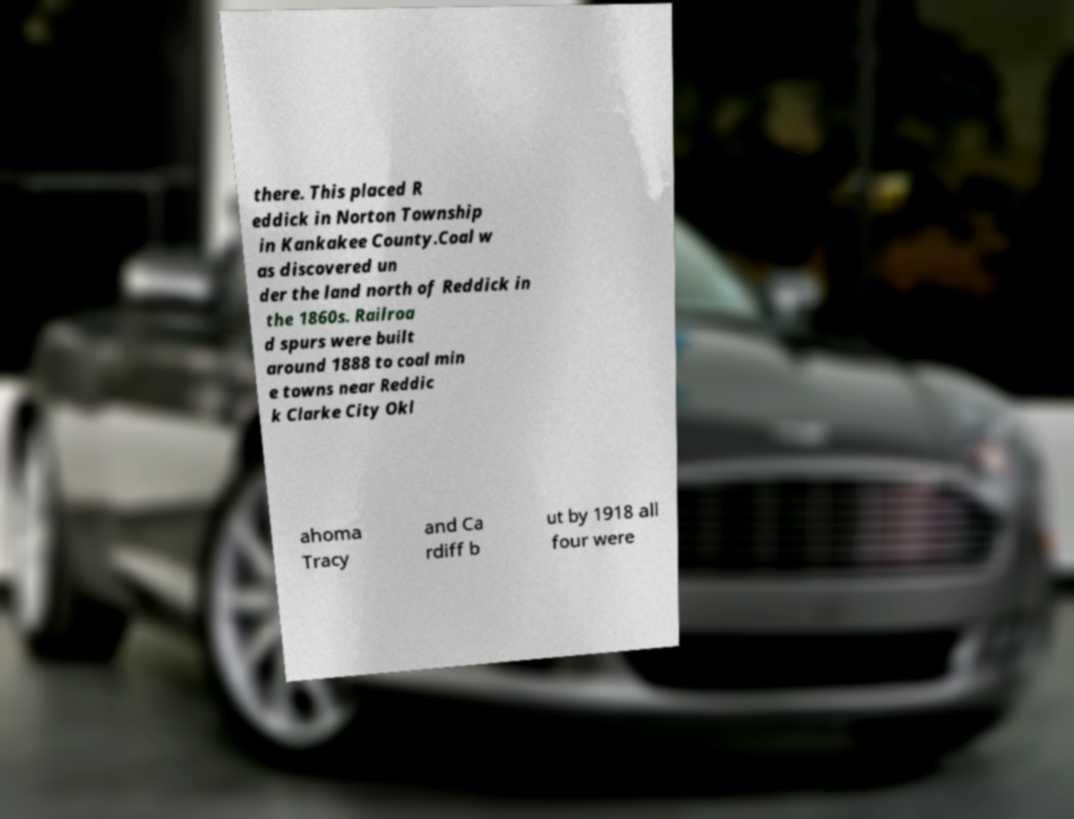Could you assist in decoding the text presented in this image and type it out clearly? there. This placed R eddick in Norton Township in Kankakee County.Coal w as discovered un der the land north of Reddick in the 1860s. Railroa d spurs were built around 1888 to coal min e towns near Reddic k Clarke City Okl ahoma Tracy and Ca rdiff b ut by 1918 all four were 